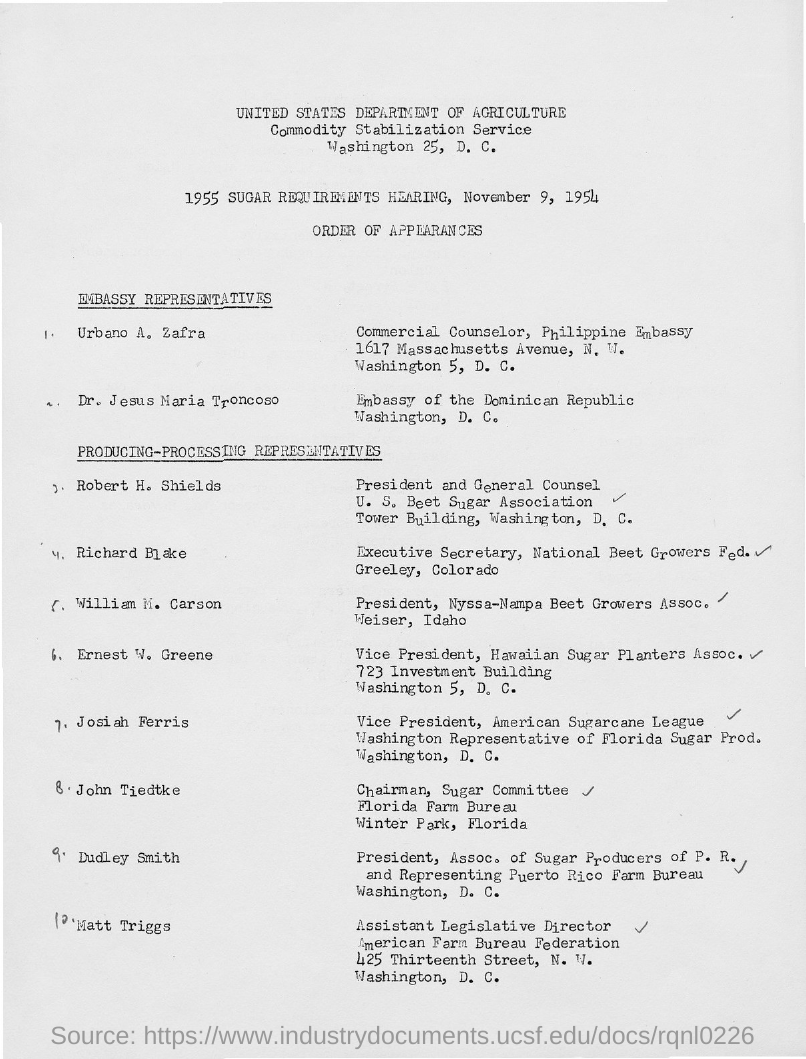When was the 1955 Sugar Requirements Hearing held?
Provide a short and direct response. November 9, 1954. What is the designation of Urbano A. Zafra?
Offer a terse response. Commercial Counselor. Who is the Chairman of Sugar Committee, Florida Farm Bureau?
Provide a short and direct response. John Tiedtke. What is the designation of William M. Carson?
Keep it short and to the point. President, Nyssa-Nampa Beet Growers Assoc. 